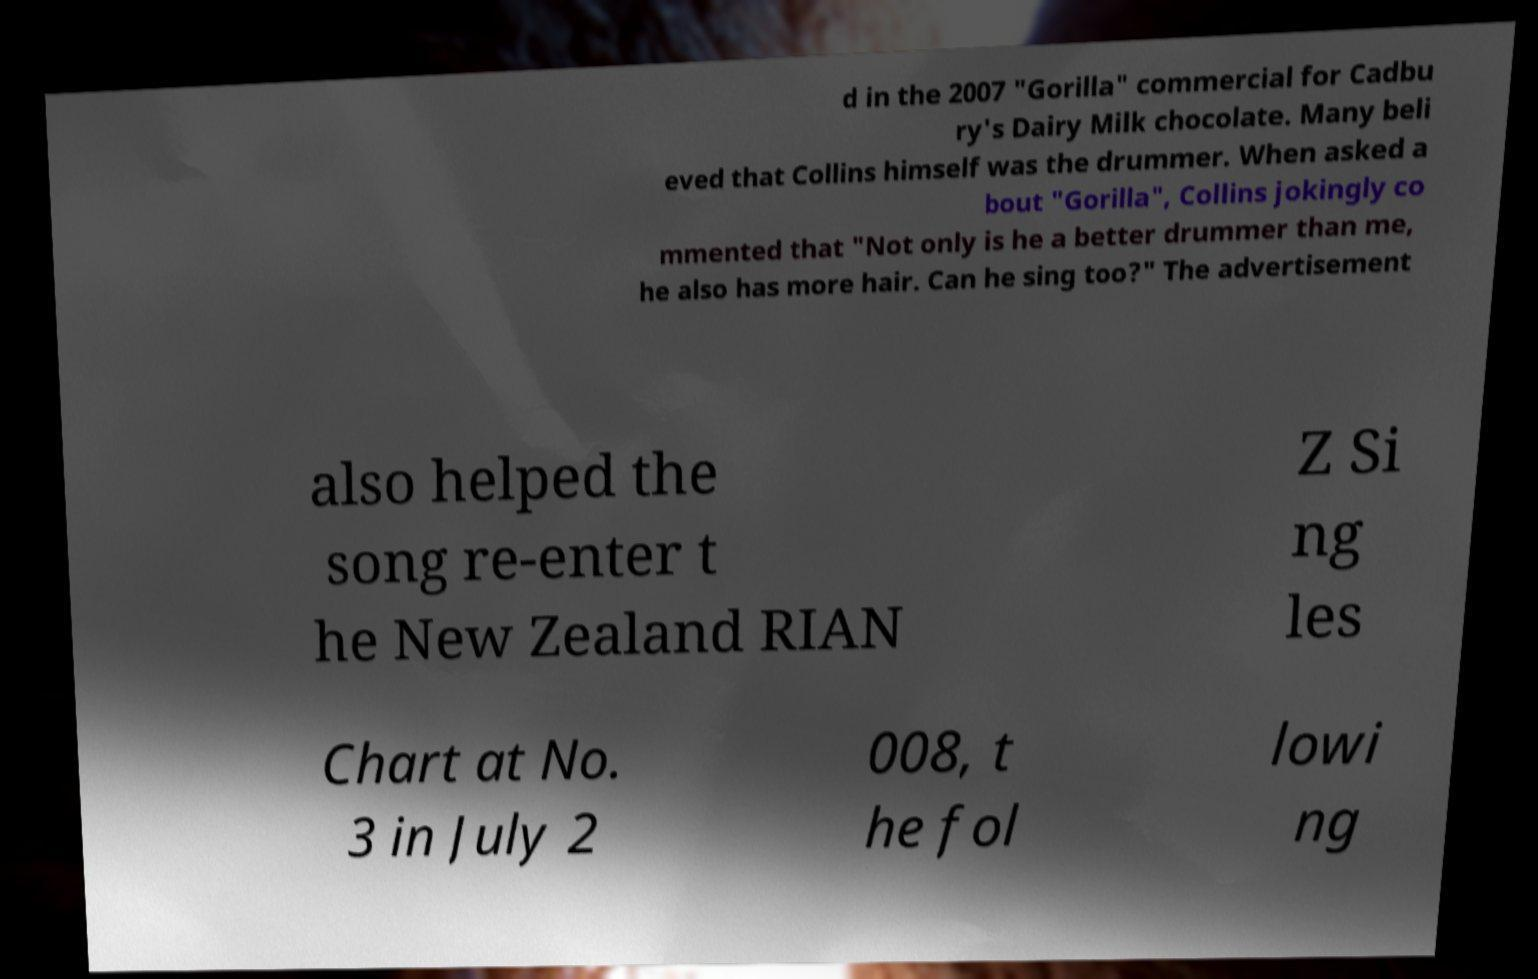Can you read and provide the text displayed in the image?This photo seems to have some interesting text. Can you extract and type it out for me? d in the 2007 "Gorilla" commercial for Cadbu ry's Dairy Milk chocolate. Many beli eved that Collins himself was the drummer. When asked a bout "Gorilla", Collins jokingly co mmented that "Not only is he a better drummer than me, he also has more hair. Can he sing too?" The advertisement also helped the song re-enter t he New Zealand RIAN Z Si ng les Chart at No. 3 in July 2 008, t he fol lowi ng 